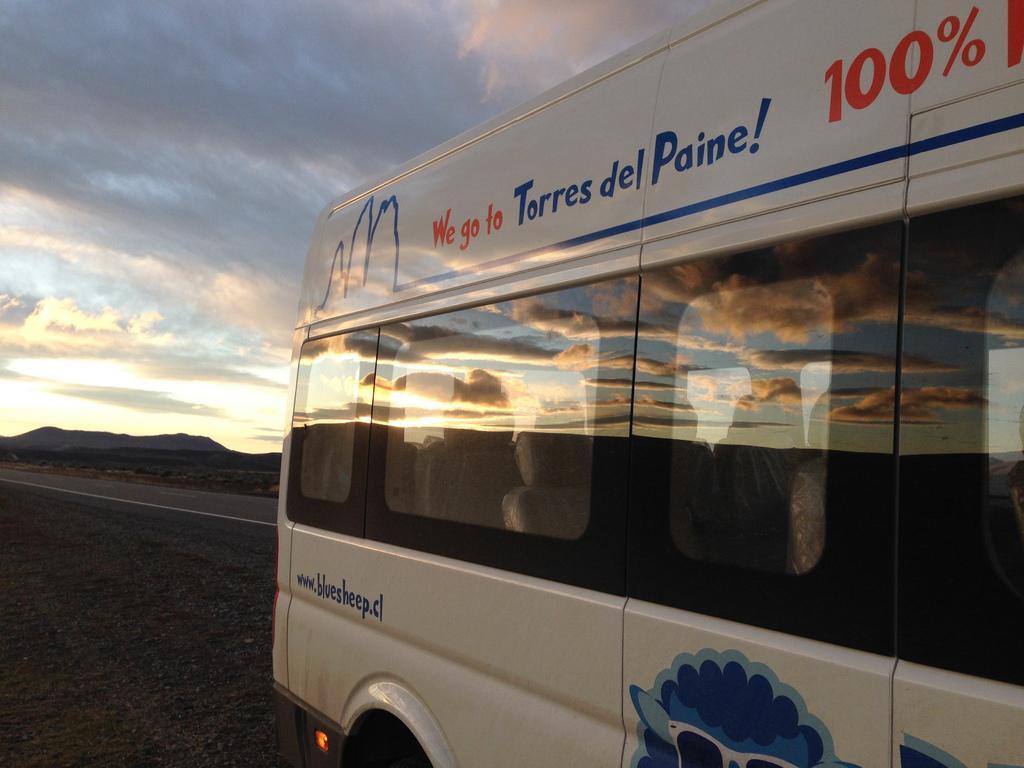Could you give a brief overview of what you see in this image? In this image I can see a white colour vehicle and on it I can see something is written. In the background I can see clouds and the sky. 